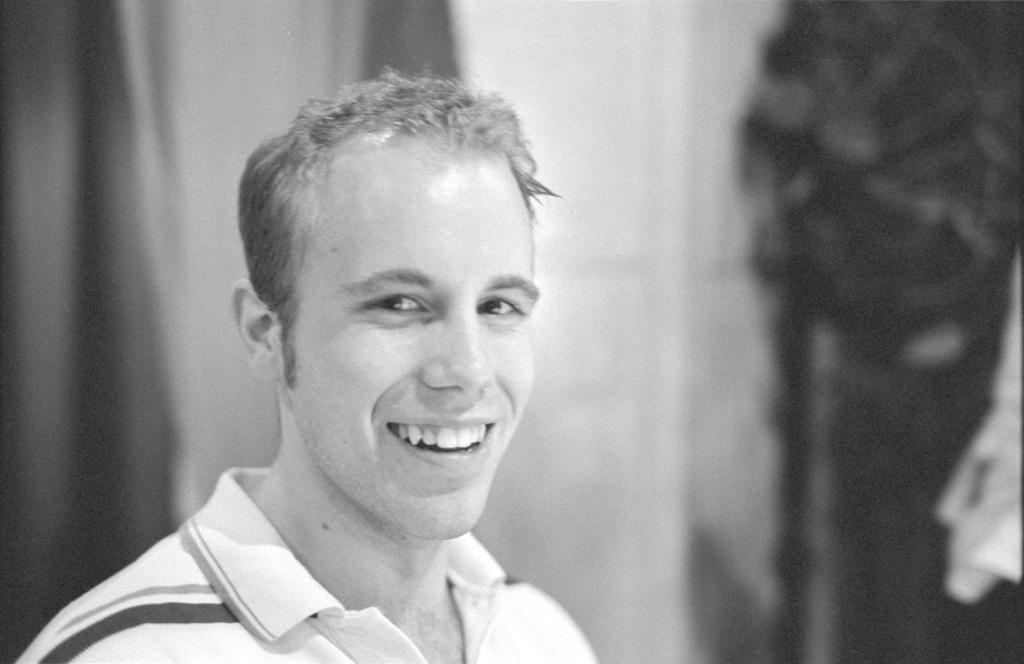What is the color scheme of the image? The image is black and white. Can you describe the main subject in the image? There is a man in the image. What colors can be seen in the background of the image? The background of the image includes white and black colors. How many trucks are visible in the image? There are no trucks present in the image. Is the man playing basketball in the image? There is no basketball or indication of basketball playing in the image. 